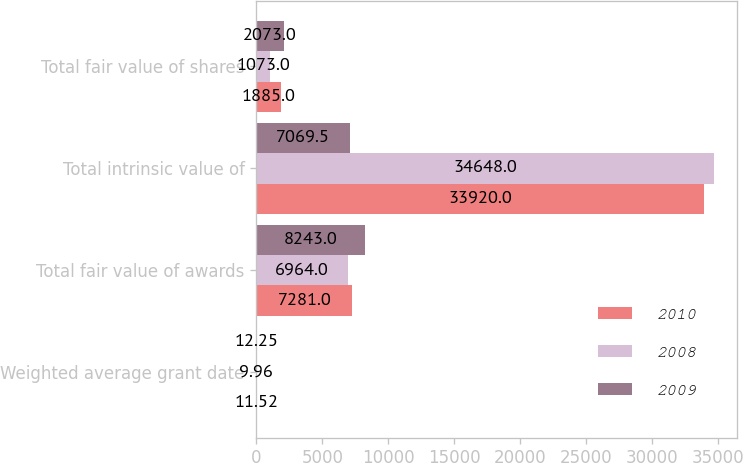<chart> <loc_0><loc_0><loc_500><loc_500><stacked_bar_chart><ecel><fcel>Weighted average grant date<fcel>Total fair value of awards<fcel>Total intrinsic value of<fcel>Total fair value of shares<nl><fcel>2010<fcel>11.52<fcel>7281<fcel>33920<fcel>1885<nl><fcel>2008<fcel>9.96<fcel>6964<fcel>34648<fcel>1073<nl><fcel>2009<fcel>12.25<fcel>8243<fcel>7069.5<fcel>2073<nl></chart> 